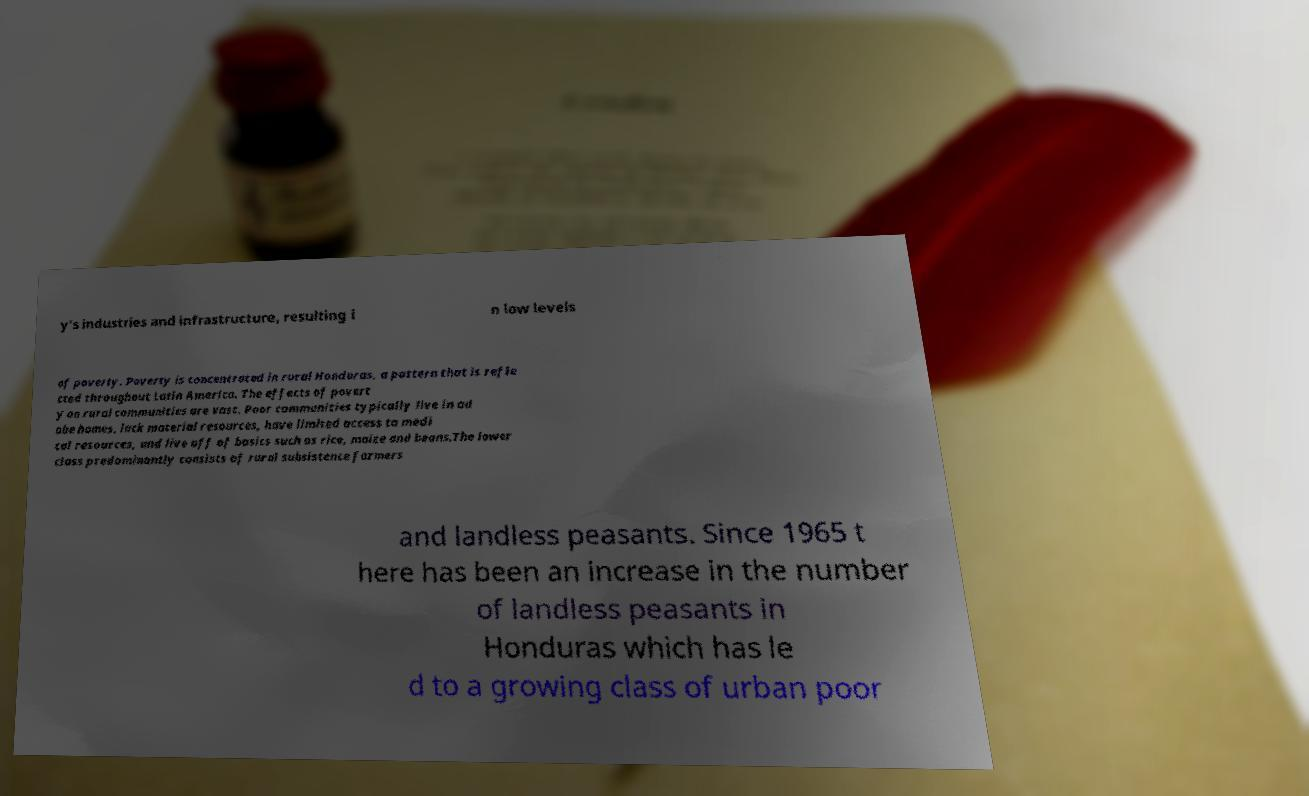Could you extract and type out the text from this image? y's industries and infrastructure, resulting i n low levels of poverty. Poverty is concentrated in rural Honduras, a pattern that is refle cted throughout Latin America. The effects of povert y on rural communities are vast. Poor communities typically live in ad obe homes, lack material resources, have limited access to medi cal resources, and live off of basics such as rice, maize and beans.The lower class predominantly consists of rural subsistence farmers and landless peasants. Since 1965 t here has been an increase in the number of landless peasants in Honduras which has le d to a growing class of urban poor 